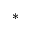Convert formula to latex. <formula><loc_0><loc_0><loc_500><loc_500>^ { * }</formula> 